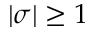<formula> <loc_0><loc_0><loc_500><loc_500>| \sigma | \geq 1</formula> 